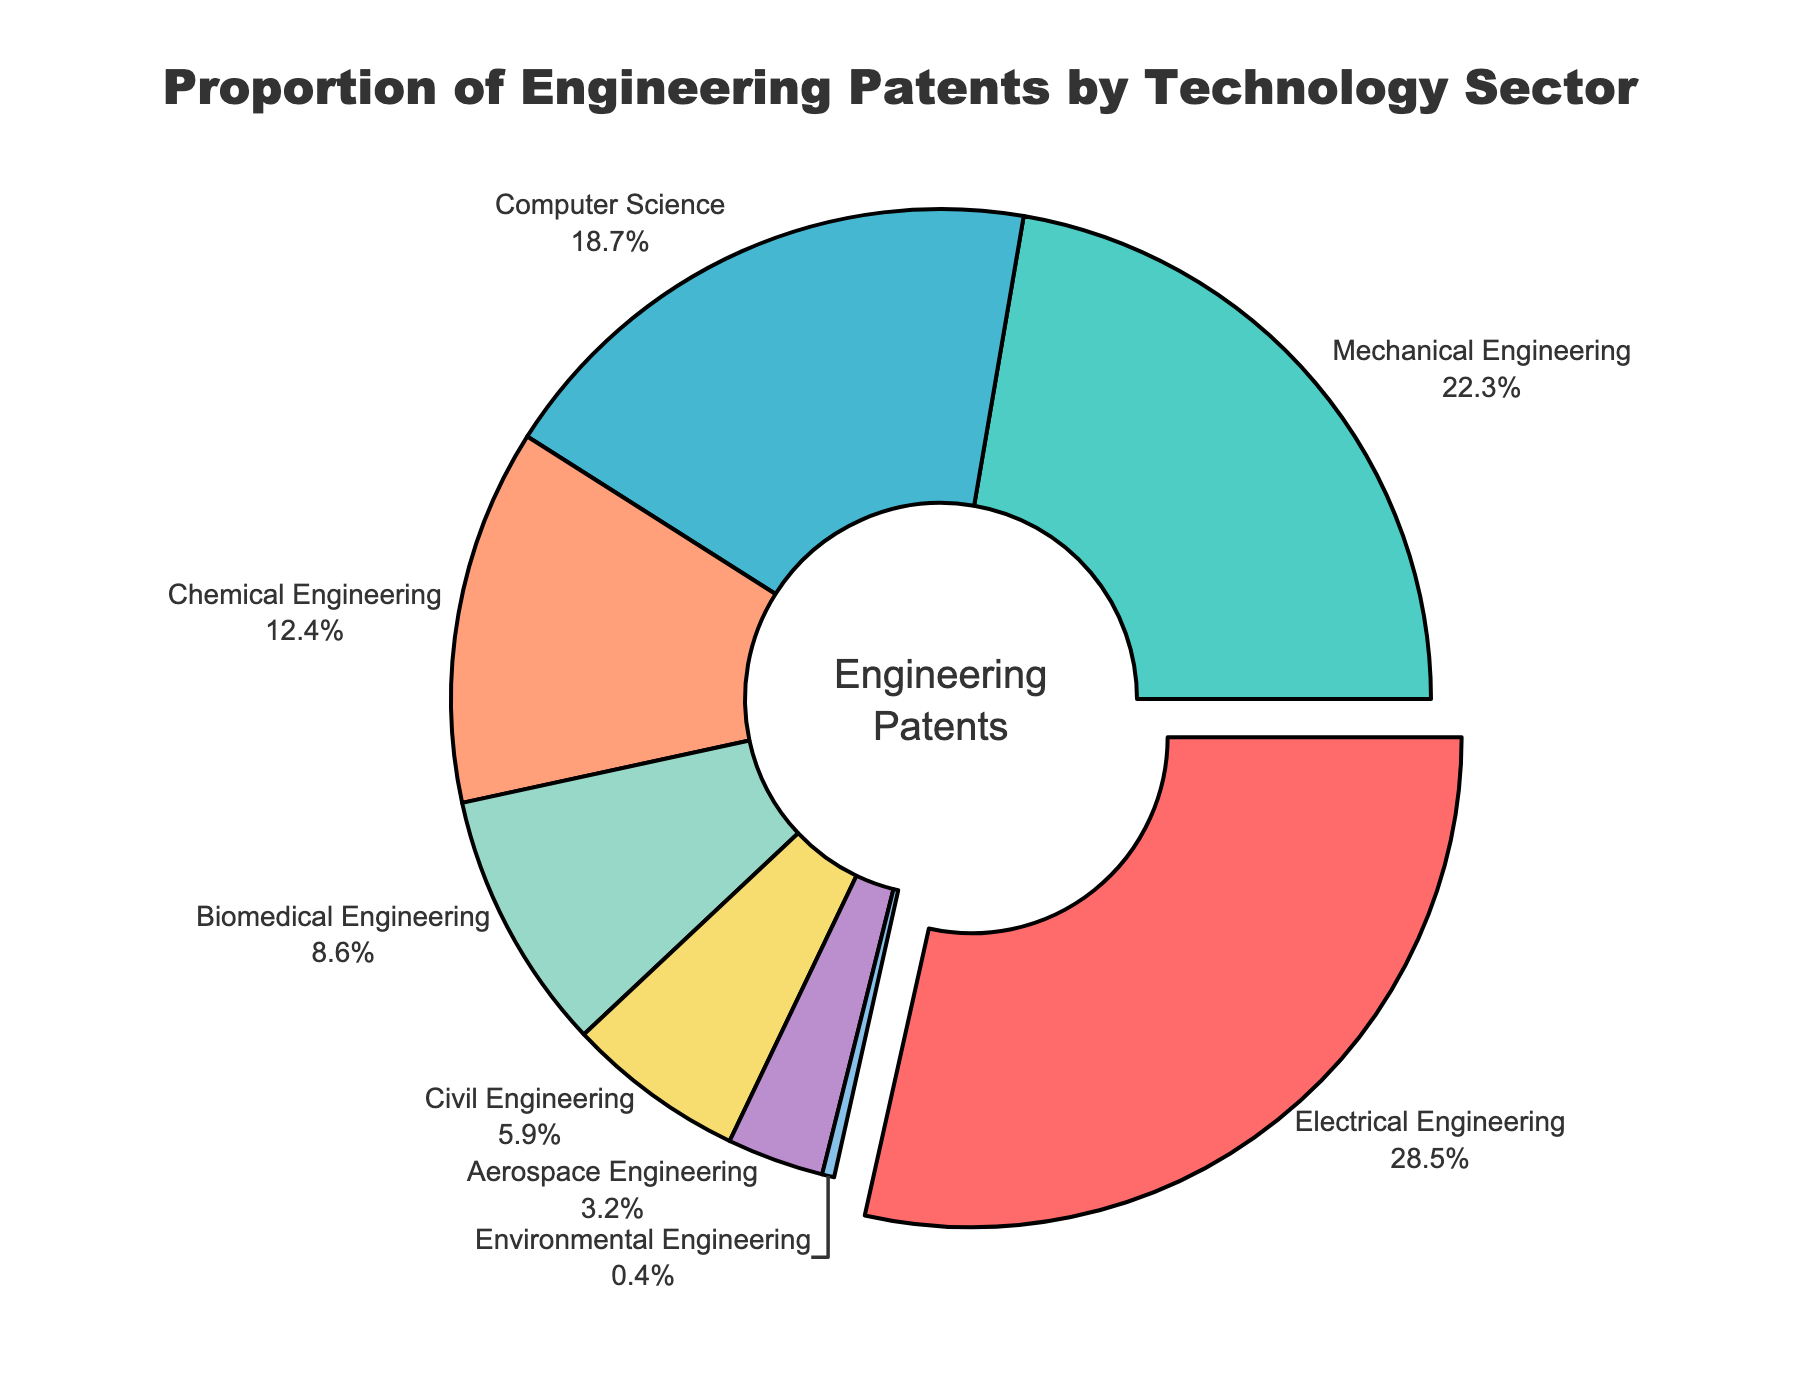What percentage of patents belongs to Biomedical Engineering? Locate the segment labeled "Biomedical Engineering" on the pie chart. Observe the percentage value associated with it.
Answer: 8.6% Which technology sector has the largest proportion of patents? Identify the segment that has been pulled out from the pie chart. The pulled-out segment represents the technology sector with the largest proportion of patents. This segment is labeled "Electrical Engineering" with 28.5%.
Answer: Electrical Engineering How does the proportion of patents in Computer Science compare to Chemical Engineering? Identify the segments labeled "Computer Science" and "Chemical Engineering." Note their corresponding percentages: Computer Science (18.7%) and Chemical Engineering (12.4%). Compare these values directly.
Answer: Computer Science has a higher proportion of patents What is the combined proportion of patents in Mechanical Engineering and Civil Engineering? Identify the segments labeled "Mechanical Engineering" and "Civil Engineering." Note their percentages: Mechanical Engineering (22.3%) and Civil Engineering (5.9%). Add these percentages to get the combined proportion: \(22.3 + 5.9 = 28.2\).
Answer: 28.2% Are there more patents in Environmental Engineering or Aerospace Engineering? Locate the segments labeled "Environmental Engineering" and "Aerospace Engineering." Note their percentages: Environmental Engineering (0.4%) and Aerospace Engineering (3.2%). Compare these values directly.
Answer: Aerospace Engineering What is the average percentage of patents for Computer Science, Chemical Engineering, and Biomedical Engineering? Identify the segments labeled "Computer Science", "Chemical Engineering", and "Biomedical Engineering." Note their percentages: Computer Science (18.7%), Chemical Engineering (12.4%), and Biomedical Engineering (8.6%). Calculate the average by summing these percentages and dividing by the number of sectors: \((18.7 + 12.4 + 8.6) / 3 = 39.7 / 3 = 13.23\).
Answer: 13.23% What is the total proportion of patents excluding Electrical Engineering? Identify the segment labeled "Electrical Engineering" and note its percentage: 28.5%. Subtract this from 100% to find the total proportion of patents for all other sectors: \(100 - 28.5 = 71.5\).
Answer: 71.5% Electrical Engineering has what percentage more patents than Aerospace Engineering? Identify the segments labeled "Electrical Engineering" and "Aerospace Engineering." Note their percentages: Electrical Engineering (28.5%) and Aerospace Engineering (3.2%). Subtract the percentage of Aerospace Engineering from Electrical Engineering to find the difference: \(28.5 - 3.2 = 25.3\).
Answer: 25.3% What is the proportion difference between the sectors with the highest and lowest number of patents? Identify the sectors with the highest and lowest patents: Electrical Engineering (28.5%) and Environmental Engineering (0.4%). Subtract the smallest percentage from the largest: \(28.5 - 0.4 = 28.1\).
Answer: 28.1% Which sector has the closest proportion to 10% of the total patents? Identify the segment with a percentage closest to 10%. The segments are: Electrical Engineering (28.5%), Mechanical Engineering (22.3%), Computer Science (18.7%), Chemical Engineering (12.4%), Biomedical Engineering (8.6%), Civil Engineering (5.9%), Aerospace Engineering (3.2%), Environmental Engineering (0.4%). Biomedical Engineering at 8.6% is the closest.
Answer: Biomedical Engineering 